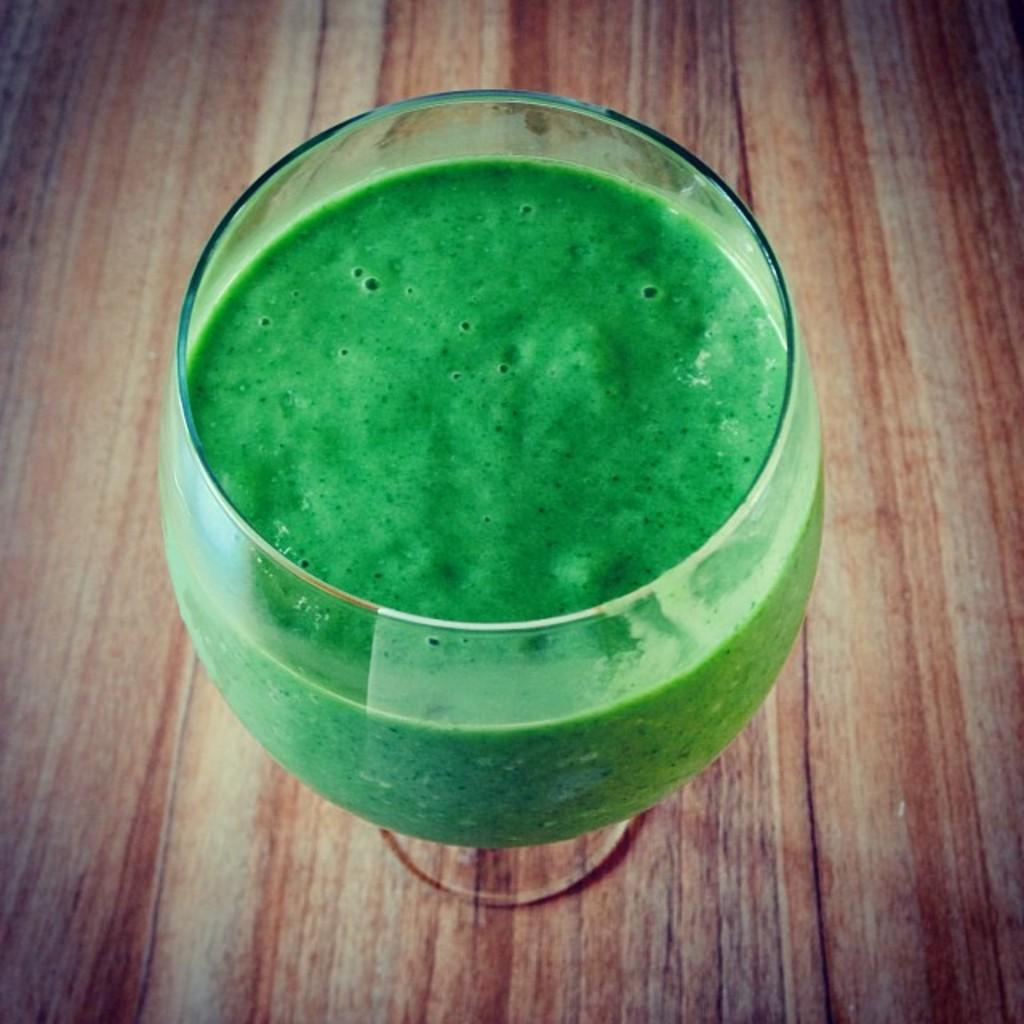What is in the glass that is visible in the image? The glass contains green thick liquid. What is the glass placed on in the image? The glass is placed on a wooden platform. How many fingers can be seen pointing at the glass in the image? There are no fingers visible in the image, as it only shows a glass with green thick liquid on a wooden platform. 